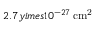Convert formula to latex. <formula><loc_0><loc_0><loc_500><loc_500>2 . 7 y i m e s 1 0 ^ { - 2 7 } \, c m ^ { 2 }</formula> 